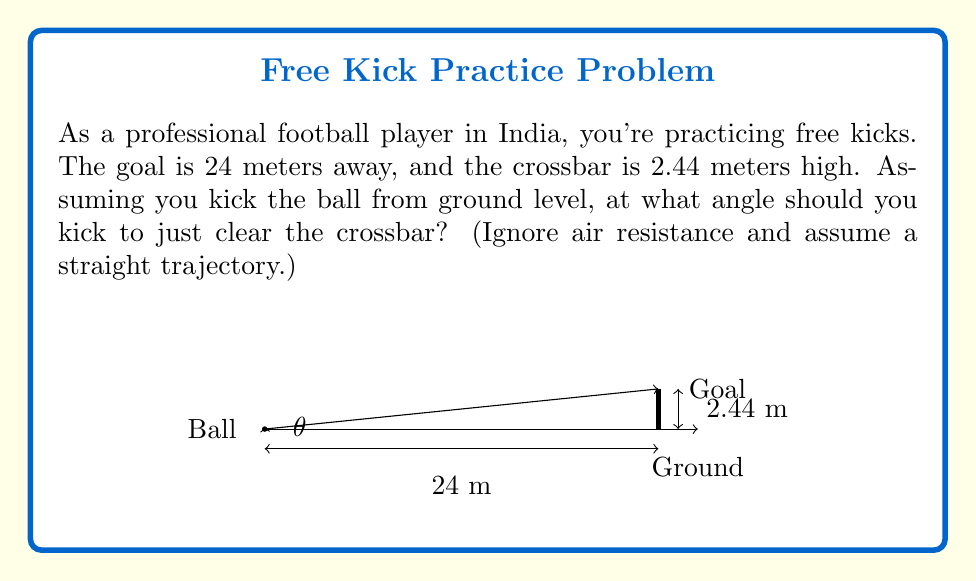Help me with this question. Let's approach this step-by-step using trigonometry:

1) We can model this situation as a right triangle, where:
   - The base of the triangle is the distance to the goal (24 m)
   - The height of the triangle is the height of the crossbar (2.44 m)
   - The hypotenuse is the path of the ball
   - The angle we're looking for is the angle between the ground and the ball's path

2) We can use the tangent function to find this angle. Recall that:

   $$\tan(\theta) = \frac{\text{opposite}}{\text{adjacent}}$$

3) In our case:
   - opposite = height of crossbar = 2.44 m
   - adjacent = distance to goal = 24 m

4) Plugging these into the tangent formula:

   $$\tan(\theta) = \frac{2.44}{24}$$

5) To find $\theta$, we need to take the inverse tangent (arctan or $\tan^{-1}$) of both sides:

   $$\theta = \tan^{-1}\left(\frac{2.44}{24}\right)$$

6) Using a calculator or computer:

   $$\theta \approx 5.8063^\circ$$

7) We round to two decimal places for practical use.
Answer: $5.81^\circ$ 